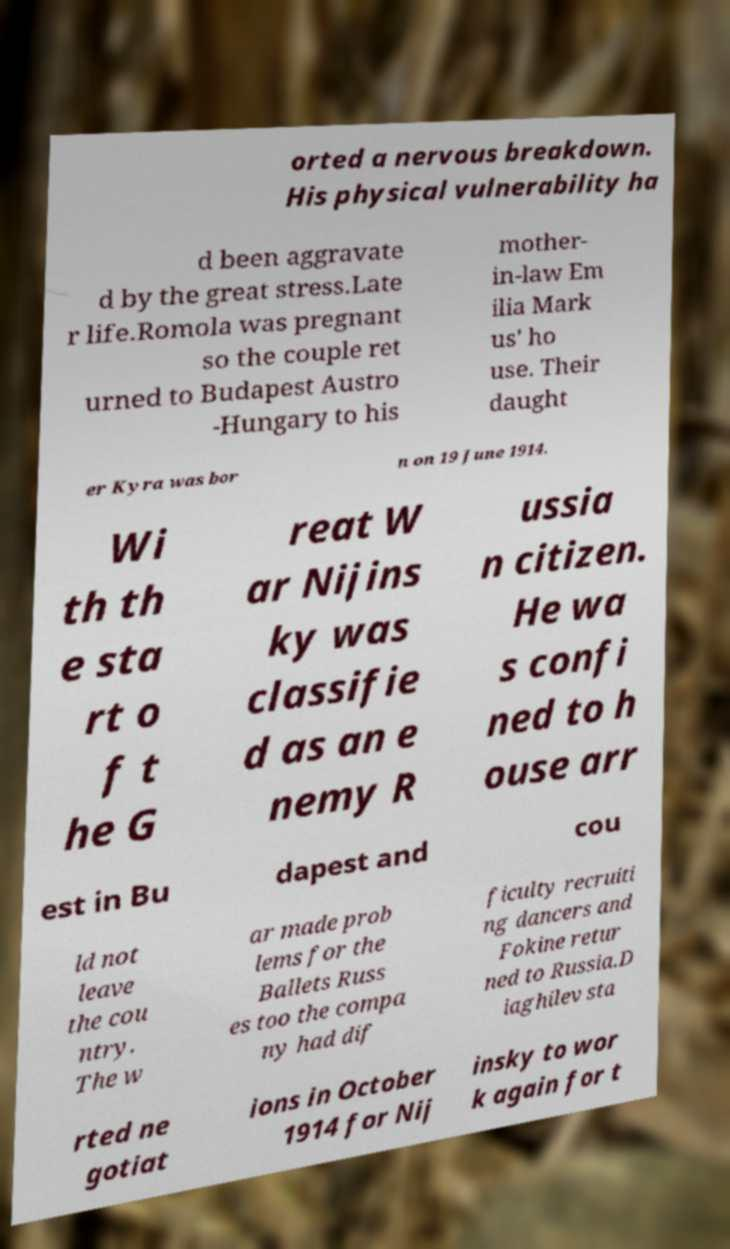Can you read and provide the text displayed in the image?This photo seems to have some interesting text. Can you extract and type it out for me? orted a nervous breakdown. His physical vulnerability ha d been aggravate d by the great stress.Late r life.Romola was pregnant so the couple ret urned to Budapest Austro -Hungary to his mother- in-law Em ilia Mark us' ho use. Their daught er Kyra was bor n on 19 June 1914. Wi th th e sta rt o f t he G reat W ar Nijins ky was classifie d as an e nemy R ussia n citizen. He wa s confi ned to h ouse arr est in Bu dapest and cou ld not leave the cou ntry. The w ar made prob lems for the Ballets Russ es too the compa ny had dif ficulty recruiti ng dancers and Fokine retur ned to Russia.D iaghilev sta rted ne gotiat ions in October 1914 for Nij insky to wor k again for t 